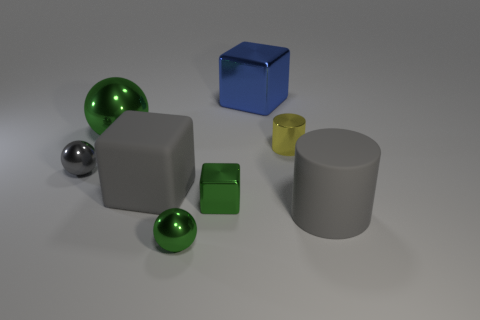There is another green shiny thing that is the same shape as the big green object; what is its size?
Your answer should be compact. Small. How many green things are the same material as the gray cylinder?
Provide a short and direct response. 0. What is the material of the green block?
Provide a succinct answer. Metal. What is the shape of the large metallic object that is behind the metal sphere behind the yellow shiny cylinder?
Offer a terse response. Cube. There is a gray object that is on the right side of the tiny yellow shiny object; what shape is it?
Provide a succinct answer. Cylinder. How many small things have the same color as the small cylinder?
Your answer should be compact. 0. What is the color of the big metallic cube?
Your answer should be very brief. Blue. There is a large object that is behind the large ball; what number of gray rubber things are right of it?
Provide a short and direct response. 1. There is a yellow metallic cylinder; is its size the same as the cylinder that is in front of the gray sphere?
Give a very brief answer. No. Do the metallic cylinder and the gray block have the same size?
Your answer should be very brief. No. 